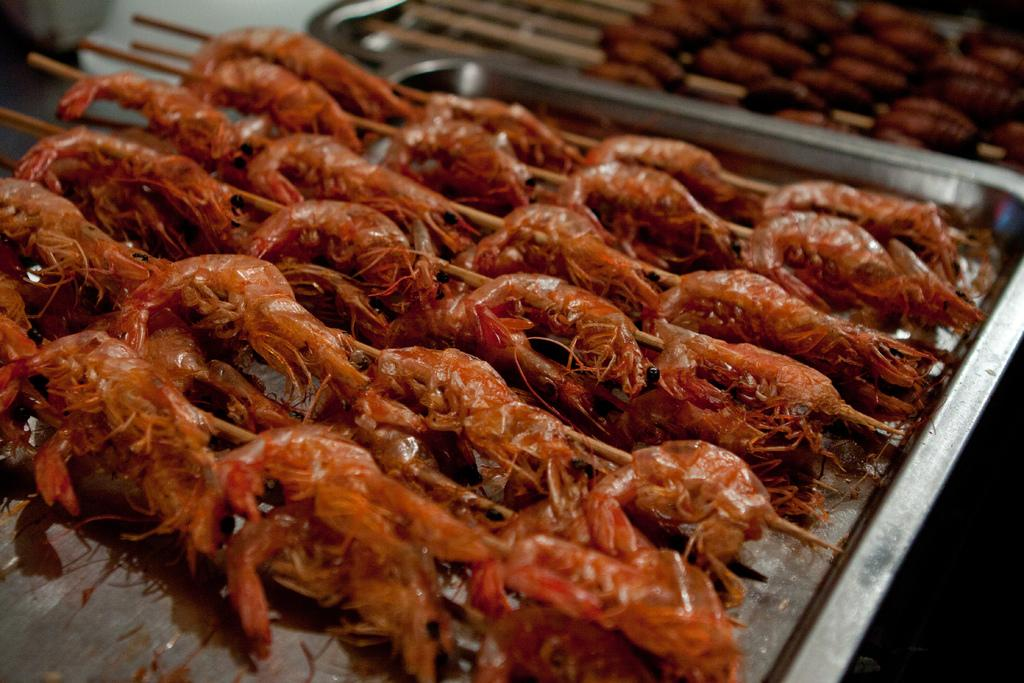How many trays are visible in the image? There are two trays in the image. What is on the trays? The trays contain shrimps. What type of mountain is visible in the image? There is no mountain present in the image; it features two trays with shrimps. What color is the lip of the person holding the tray? There is no person holding the tray in the image, so it is not possible to determine the color of their lip. 